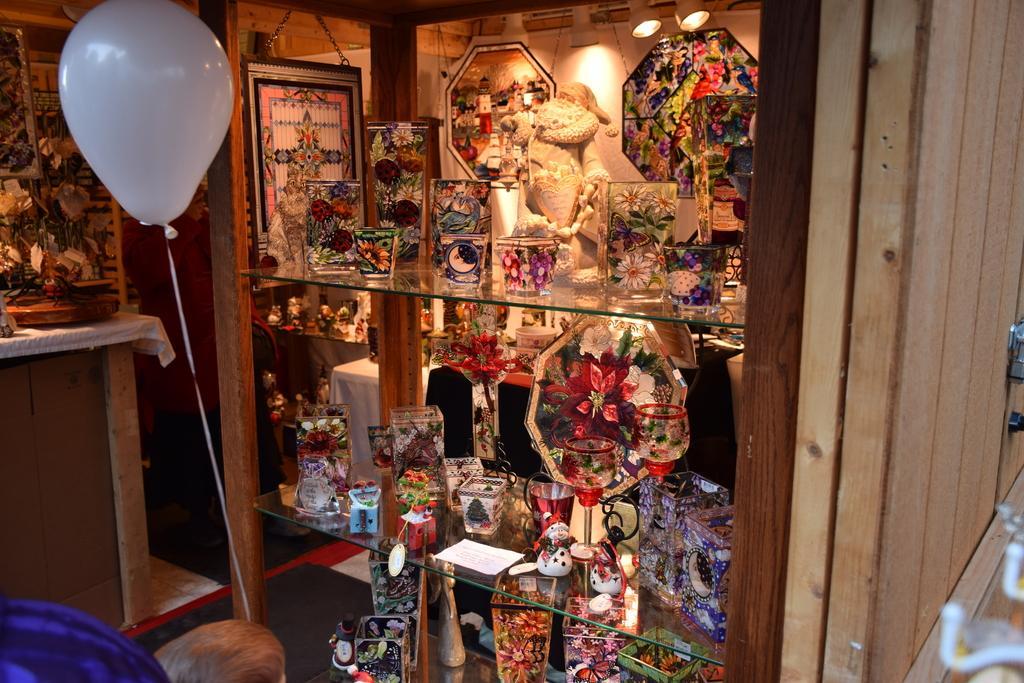In one or two sentences, can you explain what this image depicts? In this image I can see a couple of decorative objects arranged on a shelf of a wooden cupboard. I can see a potted plant. I can see a boy is standing and holding a balloon in his hand. This seems to be a gift shop. 